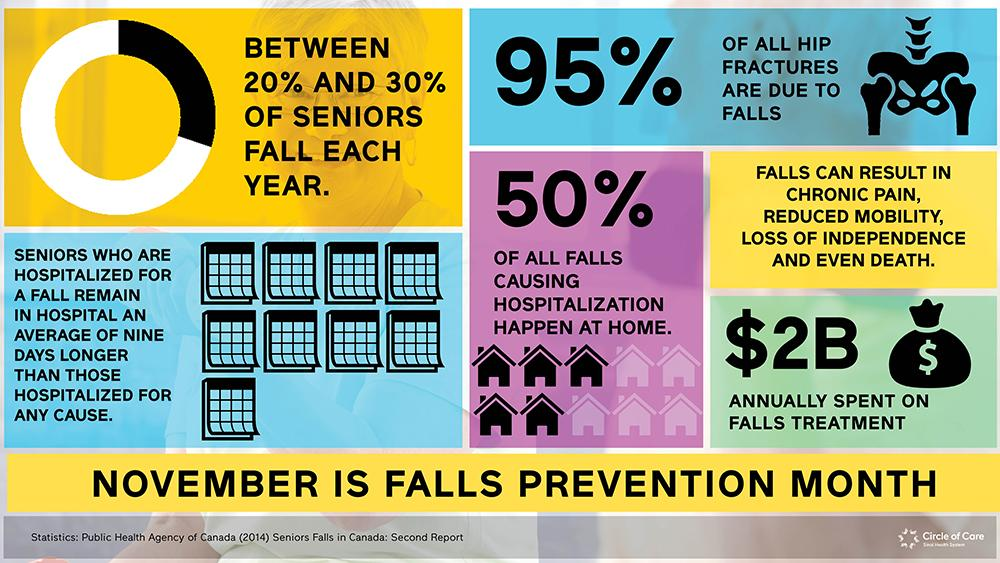Specify some key components in this picture. It is estimated that approximately 50% of hip fractures occur outside of the home. In this infographic, there are two dollar signs. The percentage of hip fractures that are not caused by falls is 5%. This infographic contains ten icons of houses. This infographic contains 5 icons depicting black houses. 